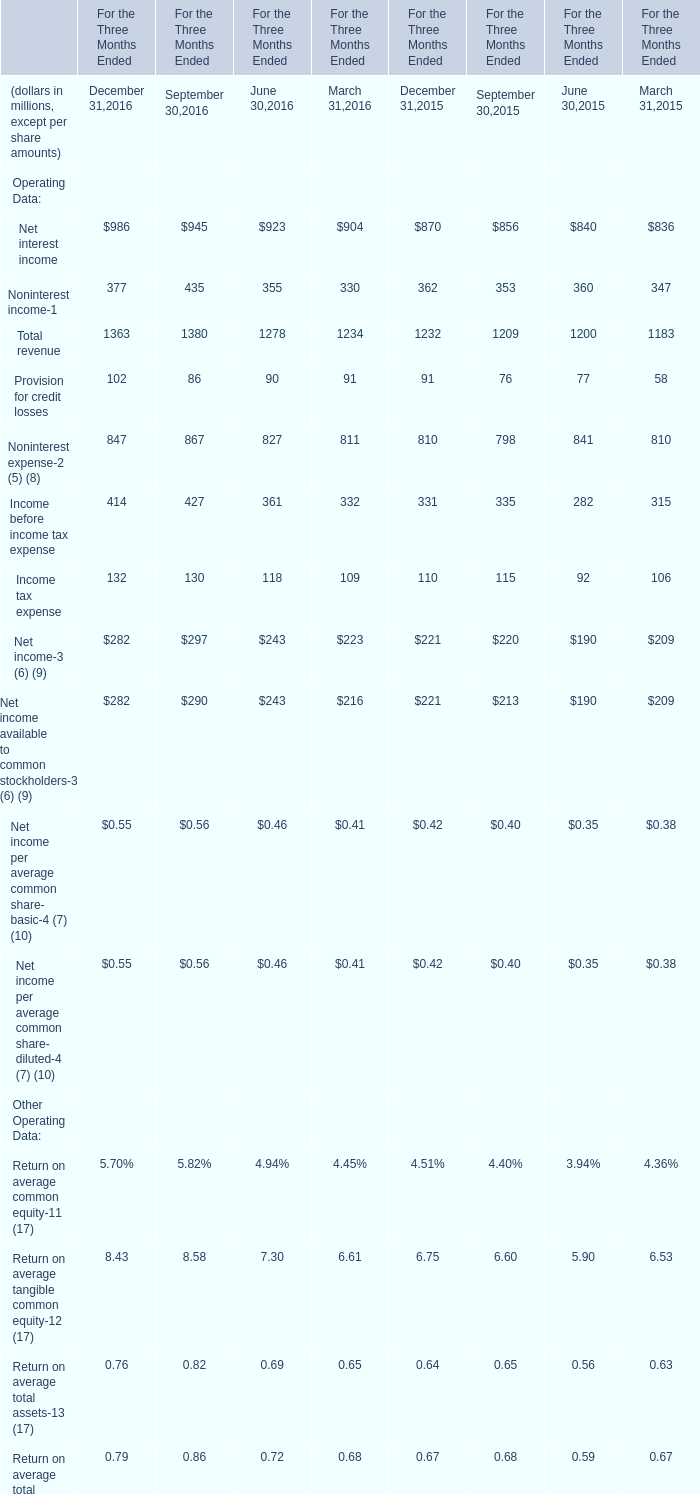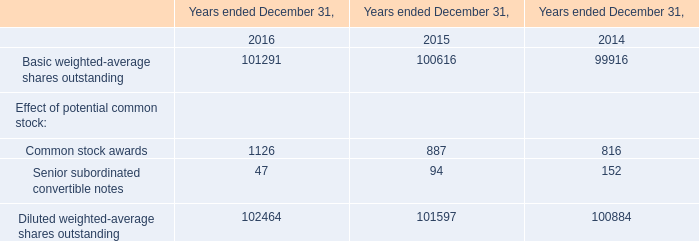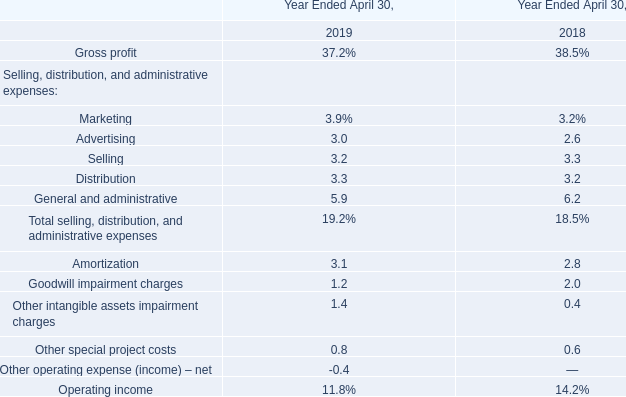What is the growing rate of Total revenue in the year with the most Net interest income? 
Computations: (((((1363 + 1380) + 1278) + 1234) - (((1232 + 1209) + 1200) + 1183)) / (((1232 + 1209) + 1200) + 1183))
Answer: 0.08934. 